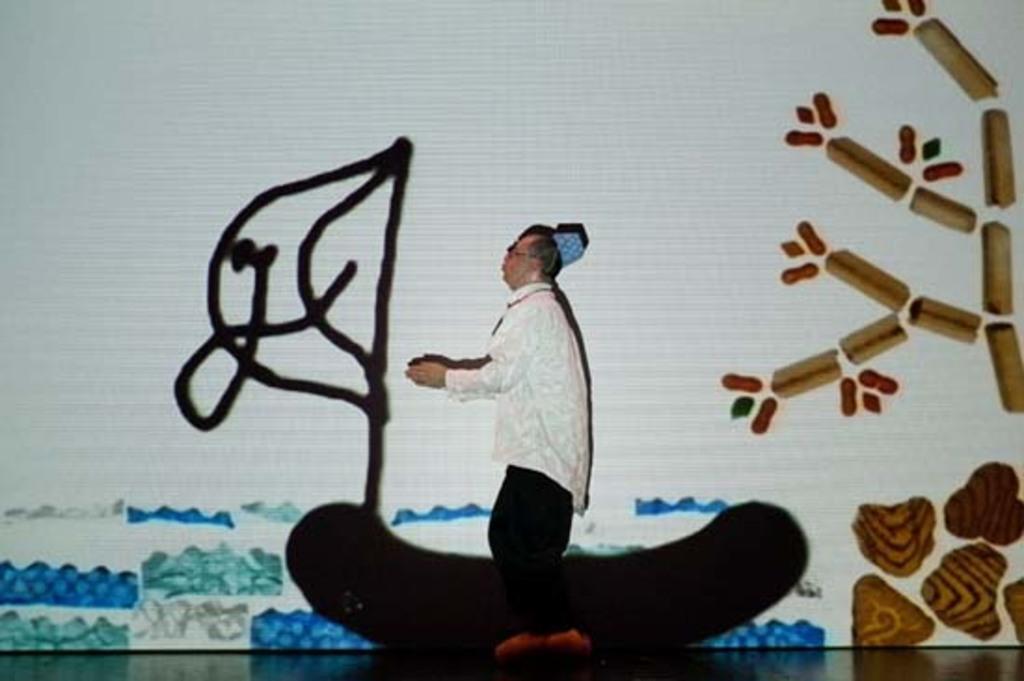Please provide a concise description of this image. In this image we can see a person is standing on the stage. There is a painting on the whiteboard. 